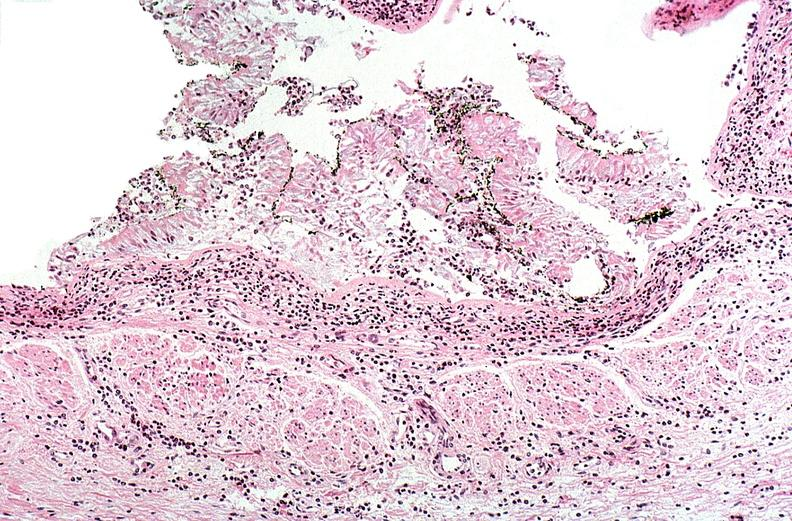does mucicarmine show thermal burn?
Answer the question using a single word or phrase. No 